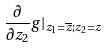Convert formula to latex. <formula><loc_0><loc_0><loc_500><loc_500>\frac { \partial } { \partial z _ { 2 } } g | _ { z _ { 1 } = \overline { z } ; z _ { 2 } = z }</formula> 